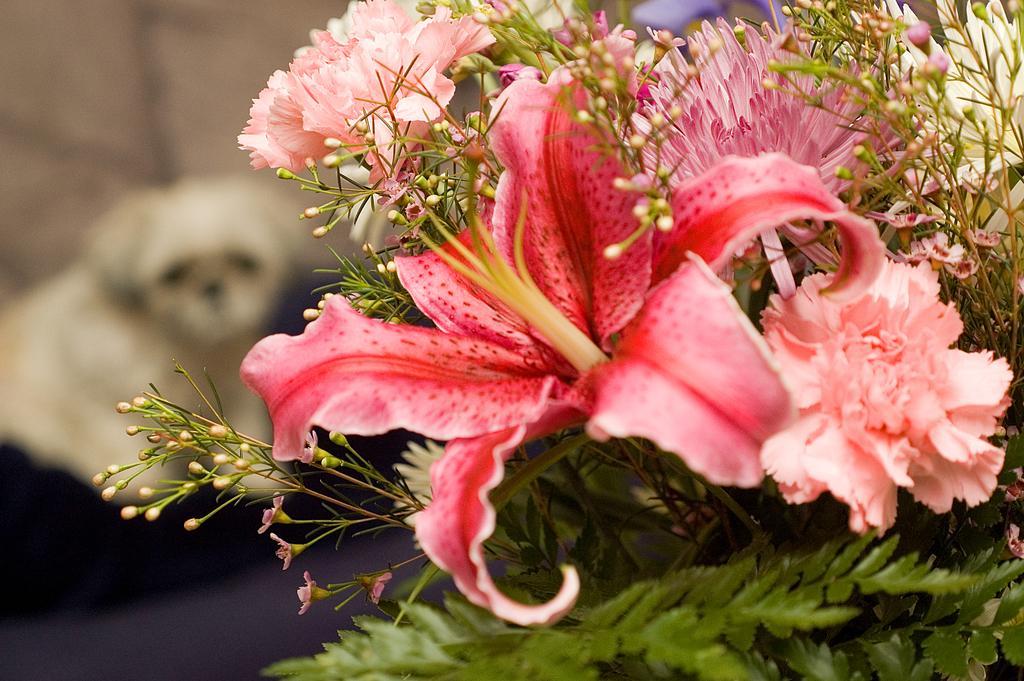In one or two sentences, can you explain what this image depicts? In this image we can see pink color flowers and leaves. It seems like a dog on the left side of the image. 